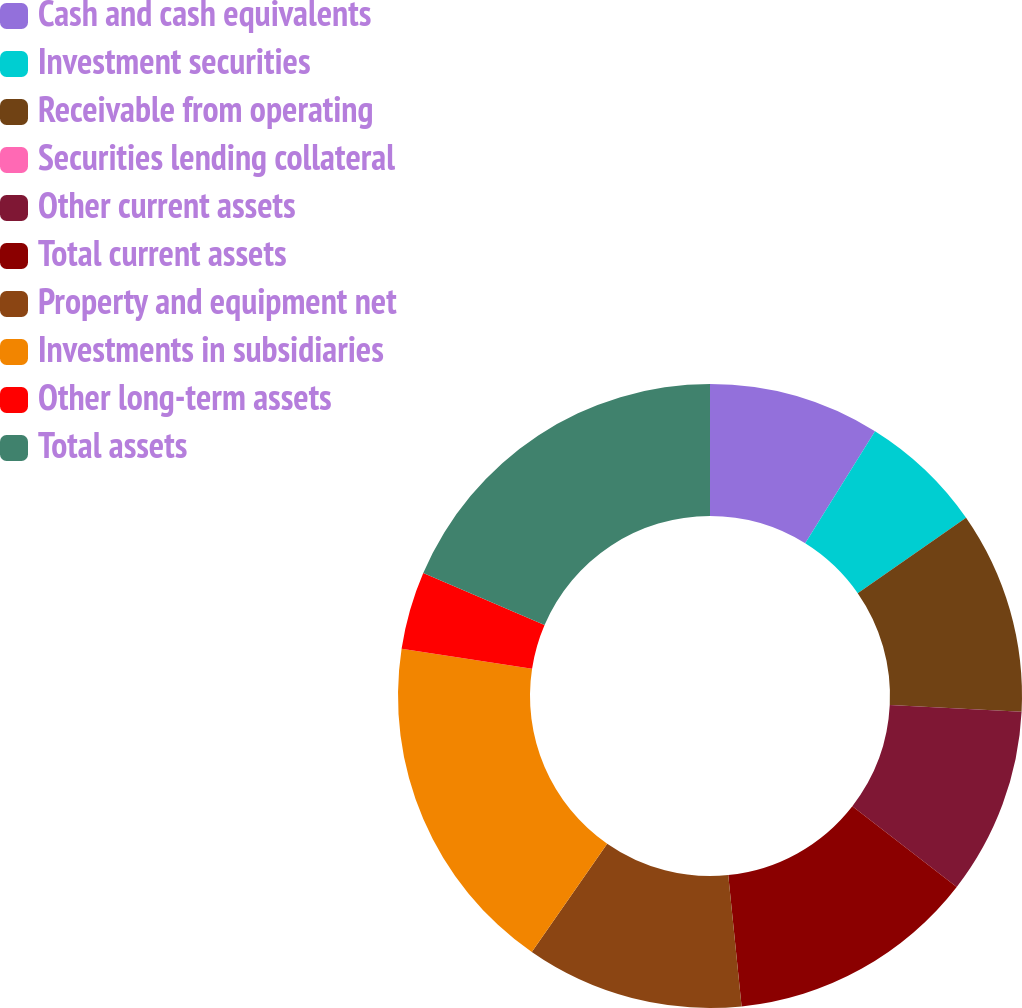<chart> <loc_0><loc_0><loc_500><loc_500><pie_chart><fcel>Cash and cash equivalents<fcel>Investment securities<fcel>Receivable from operating<fcel>Securities lending collateral<fcel>Other current assets<fcel>Total current assets<fcel>Property and equipment net<fcel>Investments in subsidiaries<fcel>Other long-term assets<fcel>Total assets<nl><fcel>8.87%<fcel>6.45%<fcel>10.48%<fcel>0.0%<fcel>9.68%<fcel>12.9%<fcel>11.29%<fcel>17.74%<fcel>4.03%<fcel>18.55%<nl></chart> 